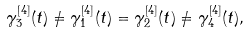Convert formula to latex. <formula><loc_0><loc_0><loc_500><loc_500>\gamma _ { 3 } ^ { [ 4 ] } ( t ) \ne \gamma _ { 1 } ^ { [ 4 ] } ( t ) = \gamma _ { 2 } ^ { [ 4 ] } ( t ) \ne \gamma _ { 4 } ^ { [ 4 ] } ( t ) ,</formula> 